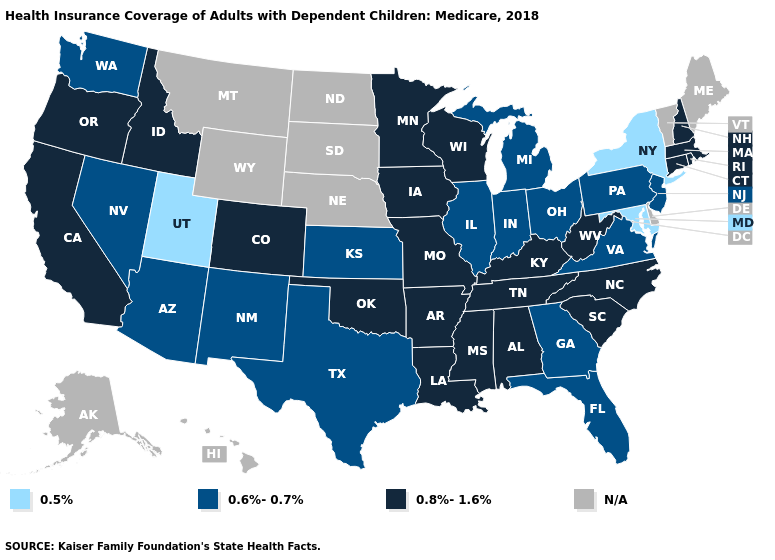What is the lowest value in the Northeast?
Be succinct. 0.5%. What is the value of Missouri?
Be succinct. 0.8%-1.6%. What is the highest value in the South ?
Concise answer only. 0.8%-1.6%. What is the value of West Virginia?
Keep it brief. 0.8%-1.6%. Name the states that have a value in the range 0.8%-1.6%?
Keep it brief. Alabama, Arkansas, California, Colorado, Connecticut, Idaho, Iowa, Kentucky, Louisiana, Massachusetts, Minnesota, Mississippi, Missouri, New Hampshire, North Carolina, Oklahoma, Oregon, Rhode Island, South Carolina, Tennessee, West Virginia, Wisconsin. What is the lowest value in the Northeast?
Concise answer only. 0.5%. Does Pennsylvania have the highest value in the Northeast?
Answer briefly. No. What is the value of West Virginia?
Quick response, please. 0.8%-1.6%. Among the states that border Oklahoma , which have the highest value?
Concise answer only. Arkansas, Colorado, Missouri. Among the states that border Massachusetts , which have the lowest value?
Give a very brief answer. New York. Name the states that have a value in the range 0.5%?
Concise answer only. Maryland, New York, Utah. What is the highest value in states that border Illinois?
Answer briefly. 0.8%-1.6%. 